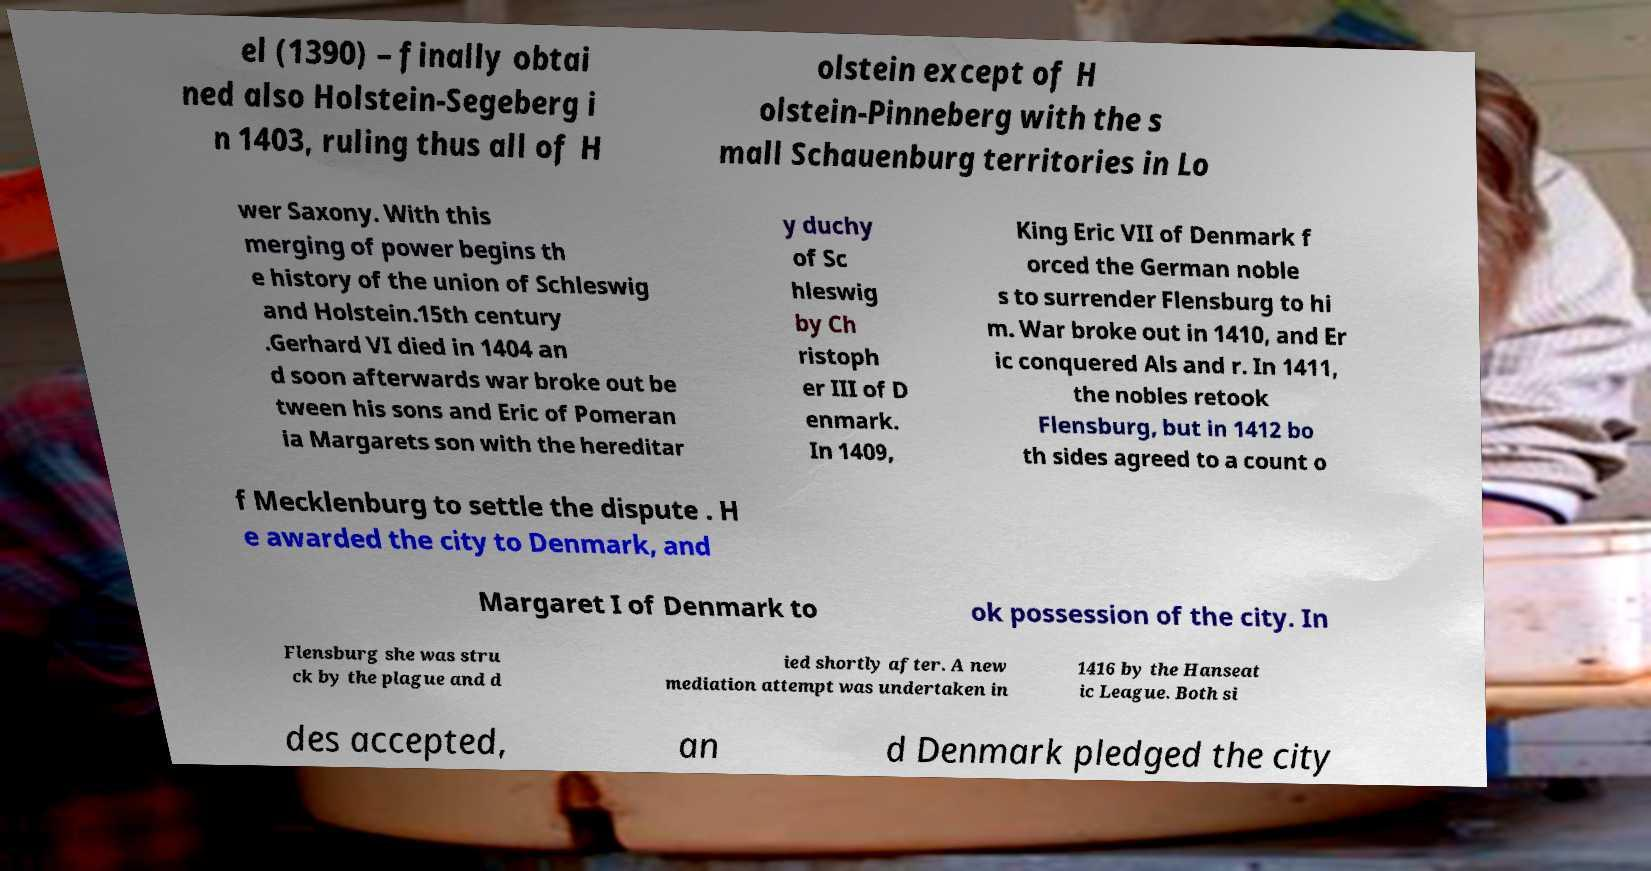Can you accurately transcribe the text from the provided image for me? el (1390) – finally obtai ned also Holstein-Segeberg i n 1403, ruling thus all of H olstein except of H olstein-Pinneberg with the s mall Schauenburg territories in Lo wer Saxony. With this merging of power begins th e history of the union of Schleswig and Holstein.15th century .Gerhard VI died in 1404 an d soon afterwards war broke out be tween his sons and Eric of Pomeran ia Margarets son with the hereditar y duchy of Sc hleswig by Ch ristoph er III of D enmark. In 1409, King Eric VII of Denmark f orced the German noble s to surrender Flensburg to hi m. War broke out in 1410, and Er ic conquered Als and r. In 1411, the nobles retook Flensburg, but in 1412 bo th sides agreed to a count o f Mecklenburg to settle the dispute . H e awarded the city to Denmark, and Margaret I of Denmark to ok possession of the city. In Flensburg she was stru ck by the plague and d ied shortly after. A new mediation attempt was undertaken in 1416 by the Hanseat ic League. Both si des accepted, an d Denmark pledged the city 